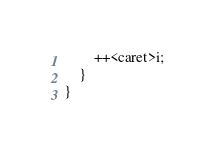<code> <loc_0><loc_0><loc_500><loc_500><_Java_>        ++<caret>i;
    }
}</code> 